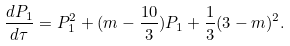Convert formula to latex. <formula><loc_0><loc_0><loc_500><loc_500>\frac { d P _ { 1 } } { d \tau } = P _ { 1 } ^ { 2 } + ( m - \frac { 1 0 } { 3 } ) P _ { 1 } + \frac { 1 } { 3 } ( 3 - m ) ^ { 2 } .</formula> 